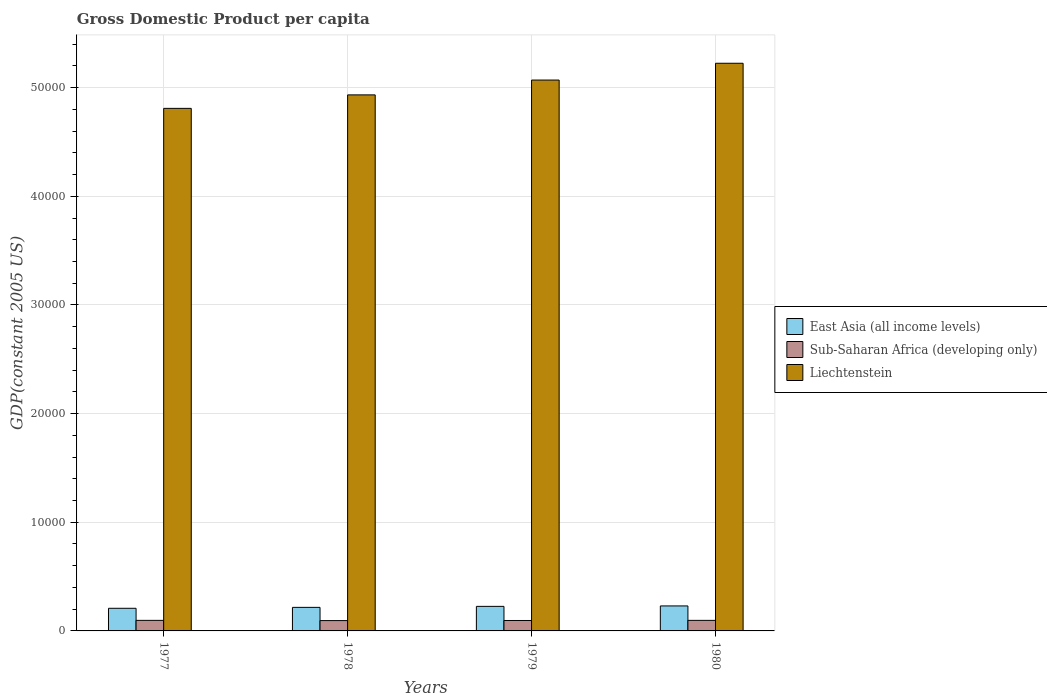How many groups of bars are there?
Provide a short and direct response. 4. How many bars are there on the 2nd tick from the left?
Give a very brief answer. 3. How many bars are there on the 4th tick from the right?
Give a very brief answer. 3. What is the label of the 2nd group of bars from the left?
Give a very brief answer. 1978. In how many cases, is the number of bars for a given year not equal to the number of legend labels?
Your answer should be compact. 0. What is the GDP per capita in East Asia (all income levels) in 1980?
Give a very brief answer. 2300.37. Across all years, what is the maximum GDP per capita in Sub-Saharan Africa (developing only)?
Provide a succinct answer. 971.63. Across all years, what is the minimum GDP per capita in East Asia (all income levels)?
Your answer should be compact. 2082.21. What is the total GDP per capita in East Asia (all income levels) in the graph?
Your answer should be very brief. 8809.74. What is the difference between the GDP per capita in Sub-Saharan Africa (developing only) in 1977 and that in 1980?
Offer a terse response. 0.94. What is the difference between the GDP per capita in Liechtenstein in 1978 and the GDP per capita in East Asia (all income levels) in 1979?
Provide a succinct answer. 4.71e+04. What is the average GDP per capita in East Asia (all income levels) per year?
Offer a very short reply. 2202.43. In the year 1979, what is the difference between the GDP per capita in Sub-Saharan Africa (developing only) and GDP per capita in East Asia (all income levels)?
Offer a terse response. -1299.43. In how many years, is the GDP per capita in East Asia (all income levels) greater than 50000 US$?
Give a very brief answer. 0. What is the ratio of the GDP per capita in East Asia (all income levels) in 1977 to that in 1978?
Provide a short and direct response. 0.96. What is the difference between the highest and the second highest GDP per capita in Sub-Saharan Africa (developing only)?
Provide a succinct answer. 0.94. What is the difference between the highest and the lowest GDP per capita in East Asia (all income levels)?
Your response must be concise. 218.16. In how many years, is the GDP per capita in Sub-Saharan Africa (developing only) greater than the average GDP per capita in Sub-Saharan Africa (developing only) taken over all years?
Your answer should be compact. 2. What does the 2nd bar from the left in 1979 represents?
Your answer should be very brief. Sub-Saharan Africa (developing only). What does the 1st bar from the right in 1980 represents?
Provide a short and direct response. Liechtenstein. How many bars are there?
Make the answer very short. 12. Are all the bars in the graph horizontal?
Give a very brief answer. No. How many legend labels are there?
Provide a short and direct response. 3. How are the legend labels stacked?
Your response must be concise. Vertical. What is the title of the graph?
Your answer should be very brief. Gross Domestic Product per capita. Does "Tuvalu" appear as one of the legend labels in the graph?
Ensure brevity in your answer.  No. What is the label or title of the X-axis?
Keep it short and to the point. Years. What is the label or title of the Y-axis?
Keep it short and to the point. GDP(constant 2005 US). What is the GDP(constant 2005 US) of East Asia (all income levels) in 1977?
Your answer should be compact. 2082.21. What is the GDP(constant 2005 US) of Sub-Saharan Africa (developing only) in 1977?
Your response must be concise. 971.63. What is the GDP(constant 2005 US) of Liechtenstein in 1977?
Your answer should be compact. 4.81e+04. What is the GDP(constant 2005 US) of East Asia (all income levels) in 1978?
Offer a very short reply. 2167.94. What is the GDP(constant 2005 US) of Sub-Saharan Africa (developing only) in 1978?
Make the answer very short. 951.17. What is the GDP(constant 2005 US) in Liechtenstein in 1978?
Your answer should be very brief. 4.93e+04. What is the GDP(constant 2005 US) of East Asia (all income levels) in 1979?
Offer a terse response. 2259.21. What is the GDP(constant 2005 US) in Sub-Saharan Africa (developing only) in 1979?
Ensure brevity in your answer.  959.78. What is the GDP(constant 2005 US) in Liechtenstein in 1979?
Give a very brief answer. 5.07e+04. What is the GDP(constant 2005 US) in East Asia (all income levels) in 1980?
Make the answer very short. 2300.37. What is the GDP(constant 2005 US) of Sub-Saharan Africa (developing only) in 1980?
Provide a short and direct response. 970.69. What is the GDP(constant 2005 US) of Liechtenstein in 1980?
Keep it short and to the point. 5.22e+04. Across all years, what is the maximum GDP(constant 2005 US) in East Asia (all income levels)?
Keep it short and to the point. 2300.37. Across all years, what is the maximum GDP(constant 2005 US) in Sub-Saharan Africa (developing only)?
Provide a short and direct response. 971.63. Across all years, what is the maximum GDP(constant 2005 US) in Liechtenstein?
Offer a terse response. 5.22e+04. Across all years, what is the minimum GDP(constant 2005 US) of East Asia (all income levels)?
Provide a succinct answer. 2082.21. Across all years, what is the minimum GDP(constant 2005 US) of Sub-Saharan Africa (developing only)?
Offer a very short reply. 951.17. Across all years, what is the minimum GDP(constant 2005 US) in Liechtenstein?
Ensure brevity in your answer.  4.81e+04. What is the total GDP(constant 2005 US) in East Asia (all income levels) in the graph?
Your answer should be compact. 8809.74. What is the total GDP(constant 2005 US) of Sub-Saharan Africa (developing only) in the graph?
Provide a short and direct response. 3853.26. What is the total GDP(constant 2005 US) of Liechtenstein in the graph?
Ensure brevity in your answer.  2.00e+05. What is the difference between the GDP(constant 2005 US) in East Asia (all income levels) in 1977 and that in 1978?
Give a very brief answer. -85.73. What is the difference between the GDP(constant 2005 US) of Sub-Saharan Africa (developing only) in 1977 and that in 1978?
Ensure brevity in your answer.  20.46. What is the difference between the GDP(constant 2005 US) in Liechtenstein in 1977 and that in 1978?
Your response must be concise. -1241.02. What is the difference between the GDP(constant 2005 US) in East Asia (all income levels) in 1977 and that in 1979?
Your response must be concise. -177. What is the difference between the GDP(constant 2005 US) in Sub-Saharan Africa (developing only) in 1977 and that in 1979?
Provide a short and direct response. 11.85. What is the difference between the GDP(constant 2005 US) of Liechtenstein in 1977 and that in 1979?
Keep it short and to the point. -2605.57. What is the difference between the GDP(constant 2005 US) of East Asia (all income levels) in 1977 and that in 1980?
Offer a very short reply. -218.16. What is the difference between the GDP(constant 2005 US) in Sub-Saharan Africa (developing only) in 1977 and that in 1980?
Offer a terse response. 0.94. What is the difference between the GDP(constant 2005 US) in Liechtenstein in 1977 and that in 1980?
Your response must be concise. -4151.63. What is the difference between the GDP(constant 2005 US) in East Asia (all income levels) in 1978 and that in 1979?
Your response must be concise. -91.27. What is the difference between the GDP(constant 2005 US) of Sub-Saharan Africa (developing only) in 1978 and that in 1979?
Keep it short and to the point. -8.61. What is the difference between the GDP(constant 2005 US) in Liechtenstein in 1978 and that in 1979?
Make the answer very short. -1364.56. What is the difference between the GDP(constant 2005 US) of East Asia (all income levels) in 1978 and that in 1980?
Make the answer very short. -132.43. What is the difference between the GDP(constant 2005 US) of Sub-Saharan Africa (developing only) in 1978 and that in 1980?
Your response must be concise. -19.52. What is the difference between the GDP(constant 2005 US) of Liechtenstein in 1978 and that in 1980?
Offer a terse response. -2910.62. What is the difference between the GDP(constant 2005 US) of East Asia (all income levels) in 1979 and that in 1980?
Keep it short and to the point. -41.16. What is the difference between the GDP(constant 2005 US) of Sub-Saharan Africa (developing only) in 1979 and that in 1980?
Keep it short and to the point. -10.91. What is the difference between the GDP(constant 2005 US) in Liechtenstein in 1979 and that in 1980?
Give a very brief answer. -1546.06. What is the difference between the GDP(constant 2005 US) in East Asia (all income levels) in 1977 and the GDP(constant 2005 US) in Sub-Saharan Africa (developing only) in 1978?
Your answer should be compact. 1131.05. What is the difference between the GDP(constant 2005 US) of East Asia (all income levels) in 1977 and the GDP(constant 2005 US) of Liechtenstein in 1978?
Keep it short and to the point. -4.72e+04. What is the difference between the GDP(constant 2005 US) in Sub-Saharan Africa (developing only) in 1977 and the GDP(constant 2005 US) in Liechtenstein in 1978?
Provide a short and direct response. -4.84e+04. What is the difference between the GDP(constant 2005 US) in East Asia (all income levels) in 1977 and the GDP(constant 2005 US) in Sub-Saharan Africa (developing only) in 1979?
Ensure brevity in your answer.  1122.43. What is the difference between the GDP(constant 2005 US) in East Asia (all income levels) in 1977 and the GDP(constant 2005 US) in Liechtenstein in 1979?
Give a very brief answer. -4.86e+04. What is the difference between the GDP(constant 2005 US) in Sub-Saharan Africa (developing only) in 1977 and the GDP(constant 2005 US) in Liechtenstein in 1979?
Keep it short and to the point. -4.97e+04. What is the difference between the GDP(constant 2005 US) of East Asia (all income levels) in 1977 and the GDP(constant 2005 US) of Sub-Saharan Africa (developing only) in 1980?
Offer a terse response. 1111.53. What is the difference between the GDP(constant 2005 US) of East Asia (all income levels) in 1977 and the GDP(constant 2005 US) of Liechtenstein in 1980?
Offer a terse response. -5.02e+04. What is the difference between the GDP(constant 2005 US) in Sub-Saharan Africa (developing only) in 1977 and the GDP(constant 2005 US) in Liechtenstein in 1980?
Provide a succinct answer. -5.13e+04. What is the difference between the GDP(constant 2005 US) of East Asia (all income levels) in 1978 and the GDP(constant 2005 US) of Sub-Saharan Africa (developing only) in 1979?
Make the answer very short. 1208.16. What is the difference between the GDP(constant 2005 US) of East Asia (all income levels) in 1978 and the GDP(constant 2005 US) of Liechtenstein in 1979?
Offer a terse response. -4.85e+04. What is the difference between the GDP(constant 2005 US) in Sub-Saharan Africa (developing only) in 1978 and the GDP(constant 2005 US) in Liechtenstein in 1979?
Ensure brevity in your answer.  -4.97e+04. What is the difference between the GDP(constant 2005 US) of East Asia (all income levels) in 1978 and the GDP(constant 2005 US) of Sub-Saharan Africa (developing only) in 1980?
Your answer should be compact. 1197.26. What is the difference between the GDP(constant 2005 US) of East Asia (all income levels) in 1978 and the GDP(constant 2005 US) of Liechtenstein in 1980?
Ensure brevity in your answer.  -5.01e+04. What is the difference between the GDP(constant 2005 US) in Sub-Saharan Africa (developing only) in 1978 and the GDP(constant 2005 US) in Liechtenstein in 1980?
Your answer should be compact. -5.13e+04. What is the difference between the GDP(constant 2005 US) in East Asia (all income levels) in 1979 and the GDP(constant 2005 US) in Sub-Saharan Africa (developing only) in 1980?
Keep it short and to the point. 1288.52. What is the difference between the GDP(constant 2005 US) in East Asia (all income levels) in 1979 and the GDP(constant 2005 US) in Liechtenstein in 1980?
Keep it short and to the point. -5.00e+04. What is the difference between the GDP(constant 2005 US) of Sub-Saharan Africa (developing only) in 1979 and the GDP(constant 2005 US) of Liechtenstein in 1980?
Ensure brevity in your answer.  -5.13e+04. What is the average GDP(constant 2005 US) in East Asia (all income levels) per year?
Provide a succinct answer. 2202.43. What is the average GDP(constant 2005 US) of Sub-Saharan Africa (developing only) per year?
Offer a very short reply. 963.31. What is the average GDP(constant 2005 US) of Liechtenstein per year?
Provide a succinct answer. 5.01e+04. In the year 1977, what is the difference between the GDP(constant 2005 US) in East Asia (all income levels) and GDP(constant 2005 US) in Sub-Saharan Africa (developing only)?
Give a very brief answer. 1110.58. In the year 1977, what is the difference between the GDP(constant 2005 US) of East Asia (all income levels) and GDP(constant 2005 US) of Liechtenstein?
Provide a succinct answer. -4.60e+04. In the year 1977, what is the difference between the GDP(constant 2005 US) of Sub-Saharan Africa (developing only) and GDP(constant 2005 US) of Liechtenstein?
Your response must be concise. -4.71e+04. In the year 1978, what is the difference between the GDP(constant 2005 US) in East Asia (all income levels) and GDP(constant 2005 US) in Sub-Saharan Africa (developing only)?
Give a very brief answer. 1216.78. In the year 1978, what is the difference between the GDP(constant 2005 US) of East Asia (all income levels) and GDP(constant 2005 US) of Liechtenstein?
Your answer should be very brief. -4.72e+04. In the year 1978, what is the difference between the GDP(constant 2005 US) in Sub-Saharan Africa (developing only) and GDP(constant 2005 US) in Liechtenstein?
Your response must be concise. -4.84e+04. In the year 1979, what is the difference between the GDP(constant 2005 US) in East Asia (all income levels) and GDP(constant 2005 US) in Sub-Saharan Africa (developing only)?
Keep it short and to the point. 1299.43. In the year 1979, what is the difference between the GDP(constant 2005 US) in East Asia (all income levels) and GDP(constant 2005 US) in Liechtenstein?
Ensure brevity in your answer.  -4.84e+04. In the year 1979, what is the difference between the GDP(constant 2005 US) of Sub-Saharan Africa (developing only) and GDP(constant 2005 US) of Liechtenstein?
Ensure brevity in your answer.  -4.97e+04. In the year 1980, what is the difference between the GDP(constant 2005 US) of East Asia (all income levels) and GDP(constant 2005 US) of Sub-Saharan Africa (developing only)?
Ensure brevity in your answer.  1329.68. In the year 1980, what is the difference between the GDP(constant 2005 US) in East Asia (all income levels) and GDP(constant 2005 US) in Liechtenstein?
Make the answer very short. -4.99e+04. In the year 1980, what is the difference between the GDP(constant 2005 US) of Sub-Saharan Africa (developing only) and GDP(constant 2005 US) of Liechtenstein?
Provide a succinct answer. -5.13e+04. What is the ratio of the GDP(constant 2005 US) of East Asia (all income levels) in 1977 to that in 1978?
Ensure brevity in your answer.  0.96. What is the ratio of the GDP(constant 2005 US) in Sub-Saharan Africa (developing only) in 1977 to that in 1978?
Offer a very short reply. 1.02. What is the ratio of the GDP(constant 2005 US) of Liechtenstein in 1977 to that in 1978?
Offer a very short reply. 0.97. What is the ratio of the GDP(constant 2005 US) in East Asia (all income levels) in 1977 to that in 1979?
Give a very brief answer. 0.92. What is the ratio of the GDP(constant 2005 US) of Sub-Saharan Africa (developing only) in 1977 to that in 1979?
Offer a very short reply. 1.01. What is the ratio of the GDP(constant 2005 US) in Liechtenstein in 1977 to that in 1979?
Your answer should be compact. 0.95. What is the ratio of the GDP(constant 2005 US) of East Asia (all income levels) in 1977 to that in 1980?
Ensure brevity in your answer.  0.91. What is the ratio of the GDP(constant 2005 US) of Sub-Saharan Africa (developing only) in 1977 to that in 1980?
Provide a succinct answer. 1. What is the ratio of the GDP(constant 2005 US) of Liechtenstein in 1977 to that in 1980?
Your response must be concise. 0.92. What is the ratio of the GDP(constant 2005 US) in East Asia (all income levels) in 1978 to that in 1979?
Provide a succinct answer. 0.96. What is the ratio of the GDP(constant 2005 US) of Liechtenstein in 1978 to that in 1979?
Your response must be concise. 0.97. What is the ratio of the GDP(constant 2005 US) in East Asia (all income levels) in 1978 to that in 1980?
Your answer should be very brief. 0.94. What is the ratio of the GDP(constant 2005 US) in Sub-Saharan Africa (developing only) in 1978 to that in 1980?
Make the answer very short. 0.98. What is the ratio of the GDP(constant 2005 US) of Liechtenstein in 1978 to that in 1980?
Keep it short and to the point. 0.94. What is the ratio of the GDP(constant 2005 US) of East Asia (all income levels) in 1979 to that in 1980?
Ensure brevity in your answer.  0.98. What is the ratio of the GDP(constant 2005 US) of Liechtenstein in 1979 to that in 1980?
Offer a terse response. 0.97. What is the difference between the highest and the second highest GDP(constant 2005 US) in East Asia (all income levels)?
Give a very brief answer. 41.16. What is the difference between the highest and the second highest GDP(constant 2005 US) of Sub-Saharan Africa (developing only)?
Offer a very short reply. 0.94. What is the difference between the highest and the second highest GDP(constant 2005 US) in Liechtenstein?
Keep it short and to the point. 1546.06. What is the difference between the highest and the lowest GDP(constant 2005 US) of East Asia (all income levels)?
Your answer should be very brief. 218.16. What is the difference between the highest and the lowest GDP(constant 2005 US) of Sub-Saharan Africa (developing only)?
Your answer should be compact. 20.46. What is the difference between the highest and the lowest GDP(constant 2005 US) of Liechtenstein?
Provide a succinct answer. 4151.63. 